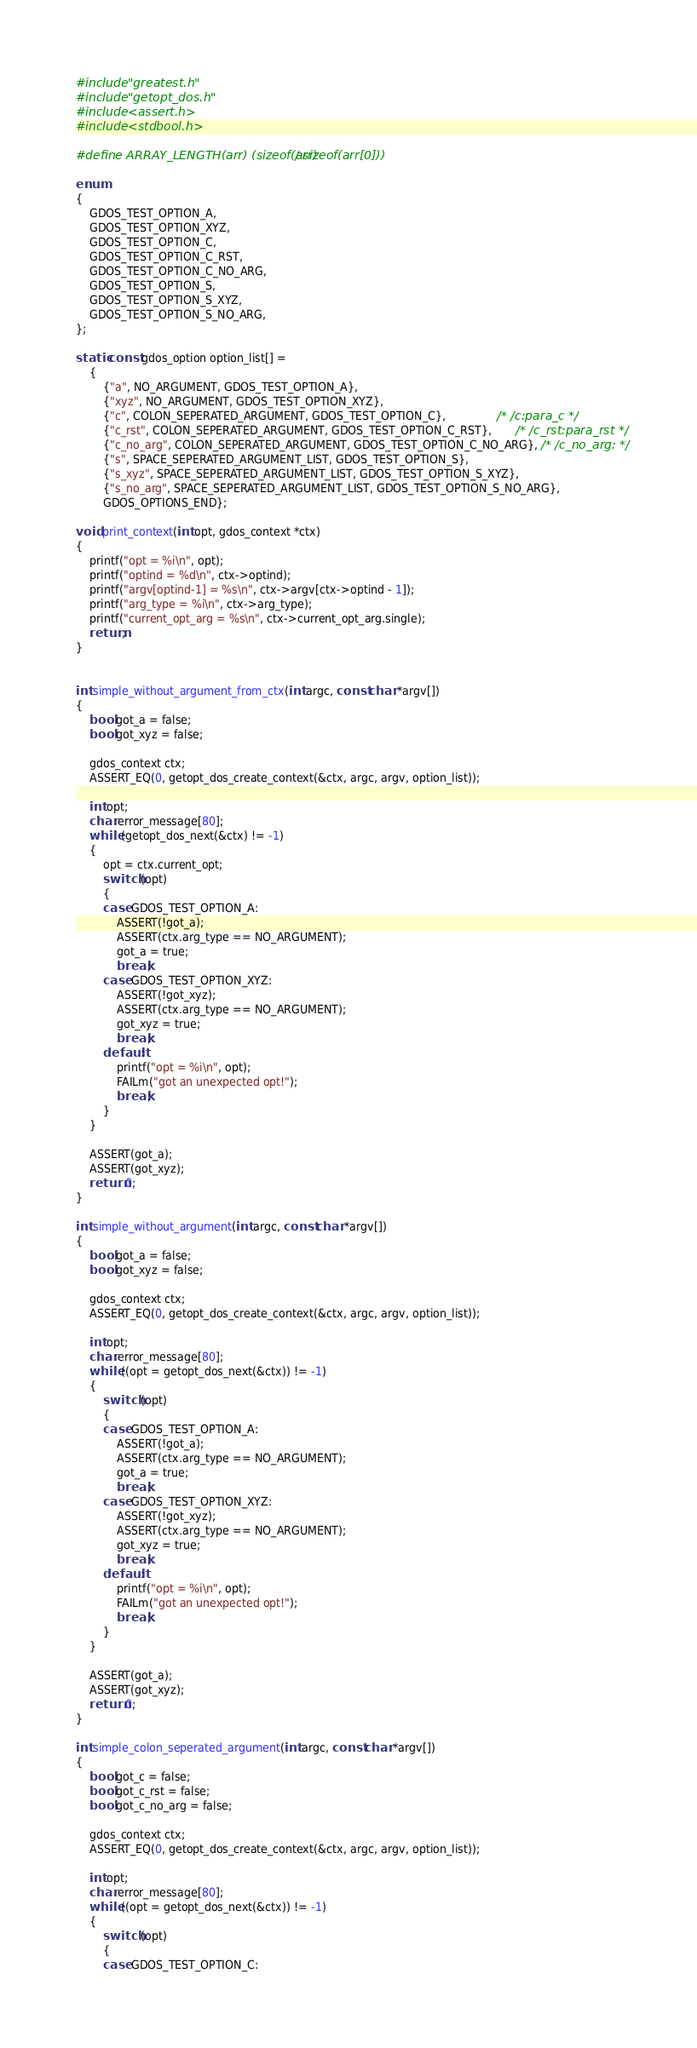<code> <loc_0><loc_0><loc_500><loc_500><_C_>#include "greatest.h"
#include "getopt_dos.h"
#include <assert.h>
#include <stdbool.h>

#define ARRAY_LENGTH(arr) (sizeof(arr) / sizeof(arr[0]))

enum
{
    GDOS_TEST_OPTION_A,
    GDOS_TEST_OPTION_XYZ,
    GDOS_TEST_OPTION_C,
    GDOS_TEST_OPTION_C_RST,
    GDOS_TEST_OPTION_C_NO_ARG,
    GDOS_TEST_OPTION_S,
    GDOS_TEST_OPTION_S_XYZ,
    GDOS_TEST_OPTION_S_NO_ARG,
};

static const gdos_option option_list[] =
    {
        {"a", NO_ARGUMENT, GDOS_TEST_OPTION_A},
        {"xyz", NO_ARGUMENT, GDOS_TEST_OPTION_XYZ},
        {"c", COLON_SEPERATED_ARGUMENT, GDOS_TEST_OPTION_C},               /* /c:para_c */
        {"c_rst", COLON_SEPERATED_ARGUMENT, GDOS_TEST_OPTION_C_RST},       /* /c_rst:para_rst */
        {"c_no_arg", COLON_SEPERATED_ARGUMENT, GDOS_TEST_OPTION_C_NO_ARG}, /* /c_no_arg: */
        {"s", SPACE_SEPERATED_ARGUMENT_LIST, GDOS_TEST_OPTION_S},
        {"s_xyz", SPACE_SEPERATED_ARGUMENT_LIST, GDOS_TEST_OPTION_S_XYZ},
        {"s_no_arg", SPACE_SEPERATED_ARGUMENT_LIST, GDOS_TEST_OPTION_S_NO_ARG},
        GDOS_OPTIONS_END};

void print_context(int opt, gdos_context *ctx)
{
    printf("opt = %i\n", opt);
    printf("optind = %d\n", ctx->optind);
    printf("argv[optind-1] = %s\n", ctx->argv[ctx->optind - 1]);
    printf("arg_type = %i\n", ctx->arg_type);
    printf("current_opt_arg = %s\n", ctx->current_opt_arg.single);
    return;
}


int simple_without_argument_from_ctx(int argc, const char *argv[])
{
    bool got_a = false;
    bool got_xyz = false;

    gdos_context ctx;
    ASSERT_EQ(0, getopt_dos_create_context(&ctx, argc, argv, option_list));

    int opt;
    char error_message[80];
    while (getopt_dos_next(&ctx) != -1)
    {
        opt = ctx.current_opt;
        switch (opt)
        {
        case GDOS_TEST_OPTION_A:
            ASSERT(!got_a);
            ASSERT(ctx.arg_type == NO_ARGUMENT);
            got_a = true;
            break;
        case GDOS_TEST_OPTION_XYZ:
            ASSERT(!got_xyz);
            ASSERT(ctx.arg_type == NO_ARGUMENT);
            got_xyz = true;
            break;
        default:
            printf("opt = %i\n", opt);
            FAILm("got an unexpected opt!");
            break;
        }
    }

    ASSERT(got_a);
    ASSERT(got_xyz);
    return 0;
}

int simple_without_argument(int argc, const char *argv[])
{
    bool got_a = false;
    bool got_xyz = false;

    gdos_context ctx;
    ASSERT_EQ(0, getopt_dos_create_context(&ctx, argc, argv, option_list));

    int opt;
    char error_message[80];
    while ((opt = getopt_dos_next(&ctx)) != -1)
    {
        switch (opt)
        {
        case GDOS_TEST_OPTION_A:
            ASSERT(!got_a);
            ASSERT(ctx.arg_type == NO_ARGUMENT);
            got_a = true;
            break;
        case GDOS_TEST_OPTION_XYZ:
            ASSERT(!got_xyz);
            ASSERT(ctx.arg_type == NO_ARGUMENT);
            got_xyz = true;
            break;
        default:
            printf("opt = %i\n", opt);
            FAILm("got an unexpected opt!");
            break;
        }
    }

    ASSERT(got_a);
    ASSERT(got_xyz);
    return 0;
}

int simple_colon_seperated_argument(int argc, const char *argv[])
{
    bool got_c = false;
    bool got_c_rst = false;
    bool got_c_no_arg = false;

    gdos_context ctx;
    ASSERT_EQ(0, getopt_dos_create_context(&ctx, argc, argv, option_list));

    int opt;
    char error_message[80];
    while ((opt = getopt_dos_next(&ctx)) != -1)
    {
        switch (opt)
        {
        case GDOS_TEST_OPTION_C:</code> 